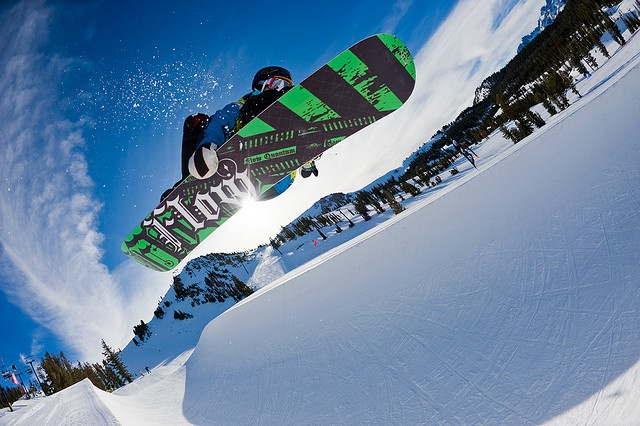Describe the objects in this image and their specific colors. I can see snowboard in navy, black, green, gray, and lightgray tones and people in navy, black, darkgray, and blue tones in this image. 